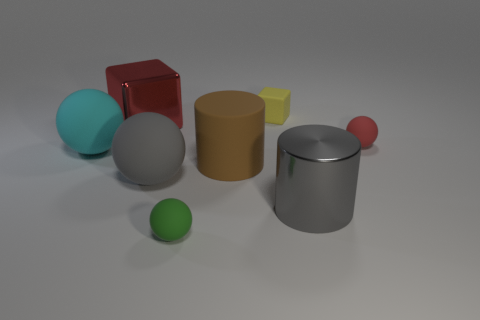Subtract all big gray balls. How many balls are left? 3 Add 2 tiny green rubber balls. How many objects exist? 10 Subtract all red balls. How many balls are left? 3 Subtract all cubes. How many objects are left? 6 Subtract 1 cylinders. How many cylinders are left? 1 Subtract all blue blocks. Subtract all gray cylinders. How many blocks are left? 2 Subtract all gray balls. How many red cubes are left? 1 Subtract all big red things. Subtract all large gray matte objects. How many objects are left? 6 Add 3 balls. How many balls are left? 7 Add 8 tiny purple spheres. How many tiny purple spheres exist? 8 